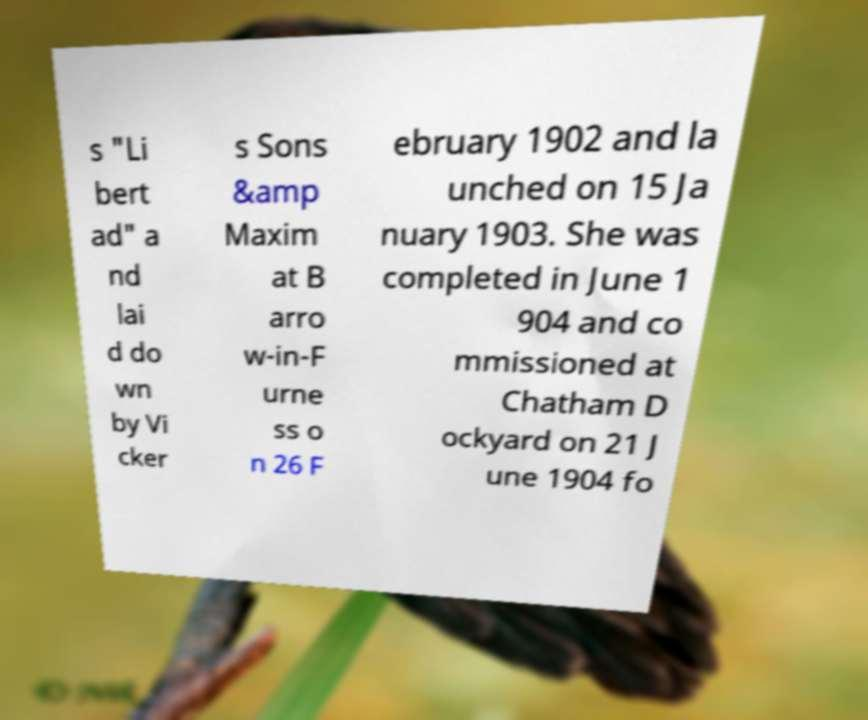There's text embedded in this image that I need extracted. Can you transcribe it verbatim? s "Li bert ad" a nd lai d do wn by Vi cker s Sons &amp Maxim at B arro w-in-F urne ss o n 26 F ebruary 1902 and la unched on 15 Ja nuary 1903. She was completed in June 1 904 and co mmissioned at Chatham D ockyard on 21 J une 1904 fo 